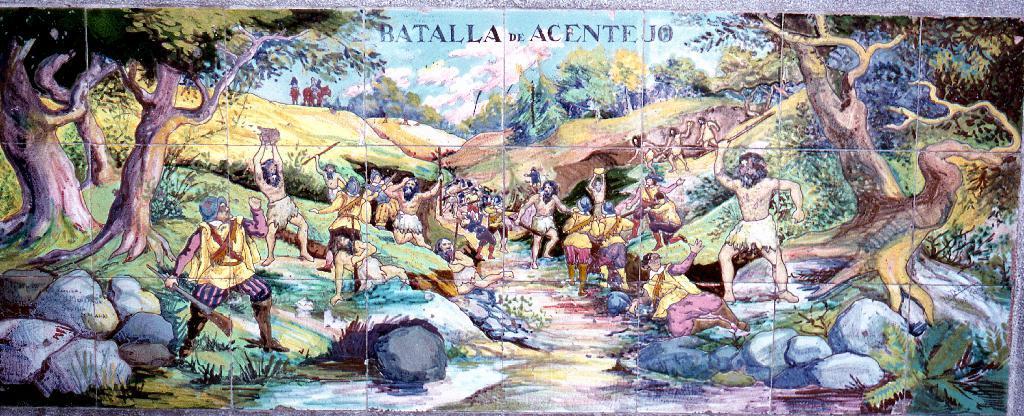In one or two sentences, can you explain what this image depicts? In the image there is a picture of some animations, there are trees, rocks and many other people. 